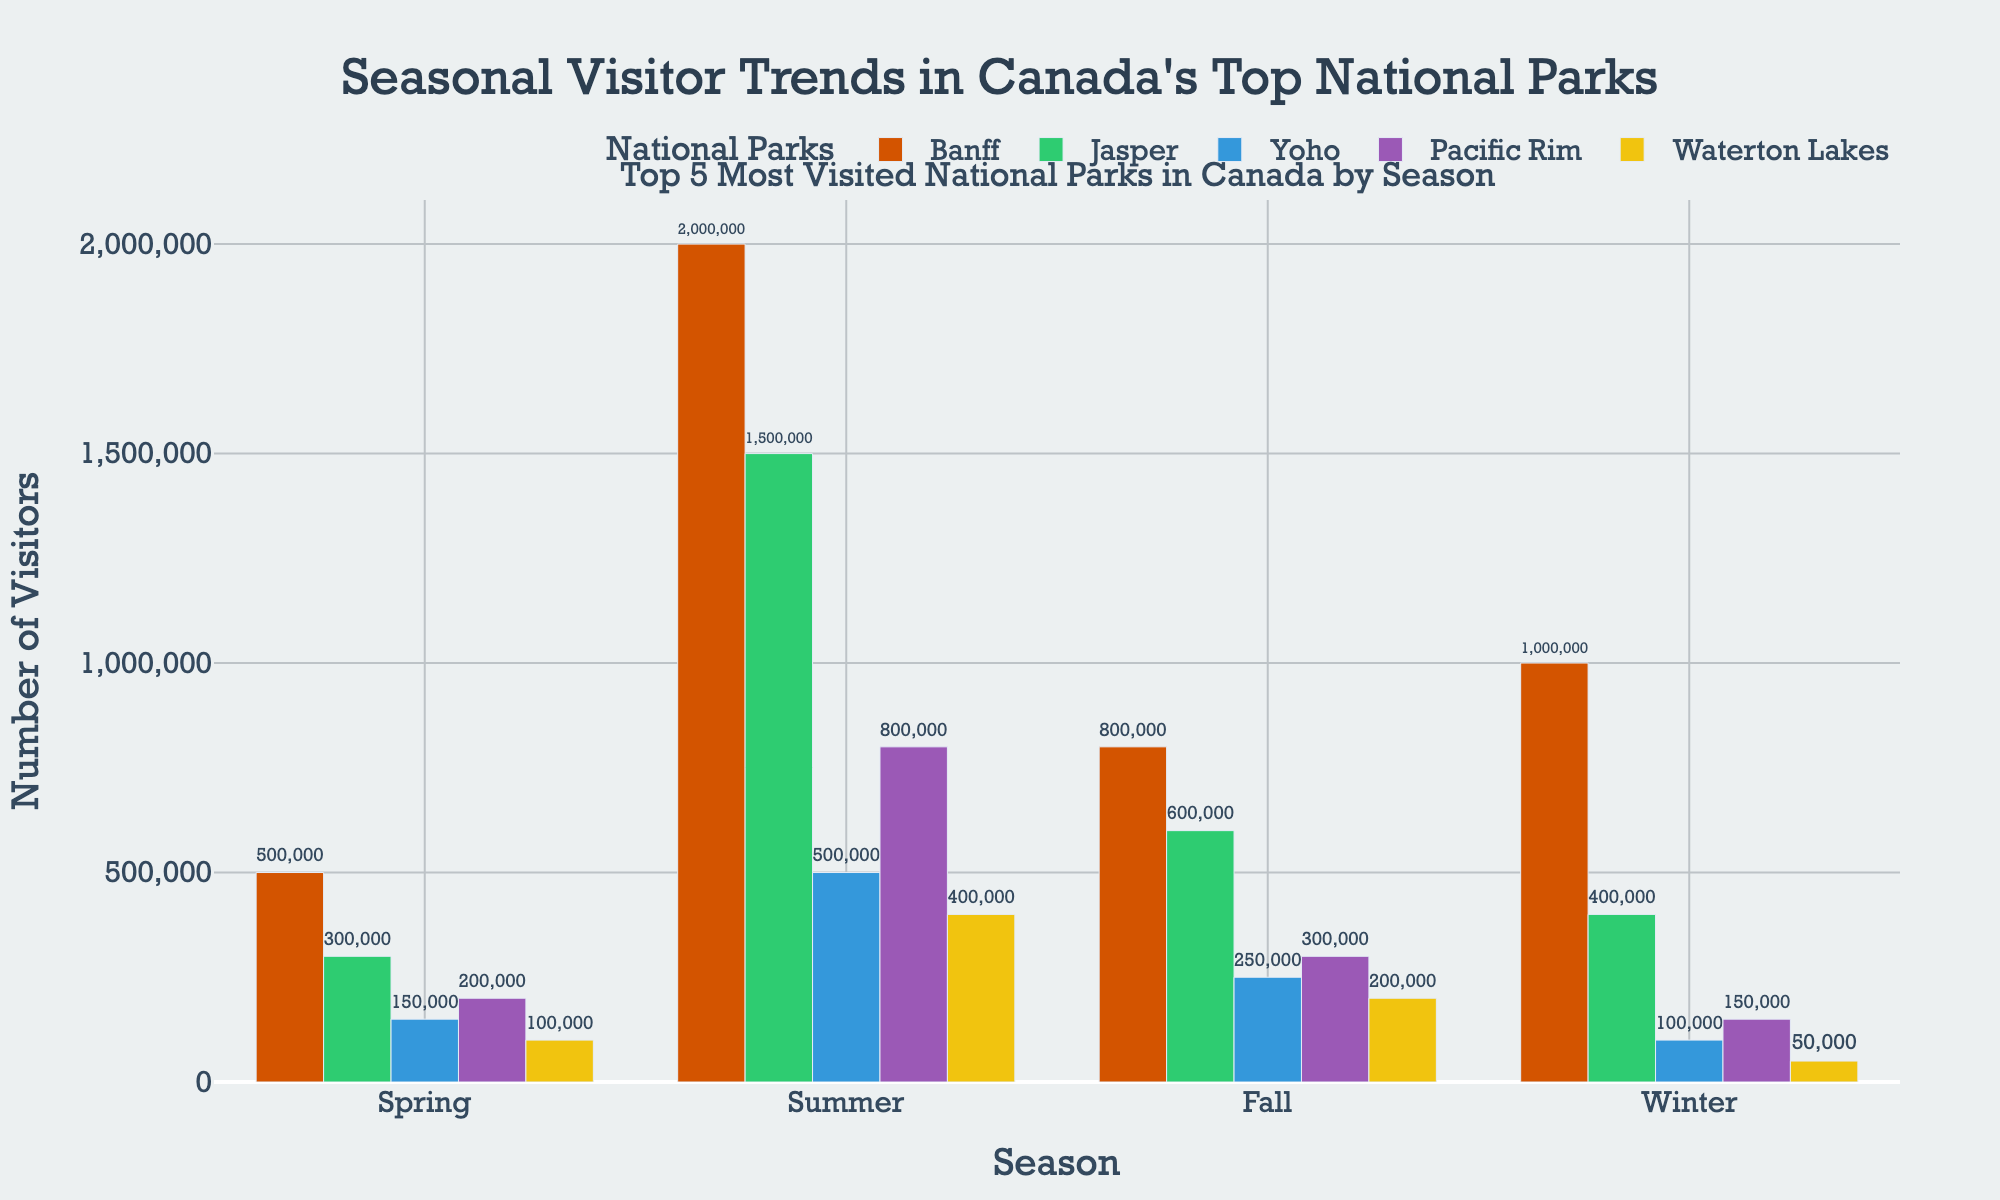Which national park has the highest number of visitors in the winter? The heights of the bars in the winter season show the number of visitors for each park. Banff has the highest bar in this season, signifying the most visitors.
Answer: Banff What is the difference in visitors between summer and winter seasons for Jasper National Park? The summer visitor count for Jasper is 1,500,000 and the winter count is 400,000. The difference is 1,500,000 - 400,000 = 1,100,000.
Answer: 1,100,000 Which season has the lowest number of visitors for Pacific Rim National Park? By comparing the heights of the bars for Pacific Rim in all seasons, the winter season has the shortest bar, indicating the lowest number of visitors.
Answer: Winter What is the total number of visitors to Yoho National Park across all seasons? Sum the visitor counts for Yoho across all seasons: 150,000 (Spring) + 500,000 (Summer) + 250,000 (Fall) + 100,000 (Winter) = 1,000,000.
Answer: 1,000,000 How does the number of summer visitors to Waterton Lakes compare to the number of fall visitors to Banff? The summer visitor count for Waterton Lakes is 400,000. The fall visitor count for Banff is 800,000. By comparison, 800,000 is greater than 400,000.
Answer: Fall visitors to Banff are more Which national park shows the most significant variation in visitor numbers across different seasons? Observe the largest range in bar heights. Banff has the most significant variation between its seasons with 500,000 in spring and 2,000,000 in summer.
Answer: Banff What is the average number of visitors per season for Yoho National Park? Calculate the average visitor count: (150,000 + 500,000 + 250,000 + 100,000) / 4 = 1,000,000 / 4 = 250,000.
Answer: 250,000 How many more visitors does Banff receive in the summer than in the spring? Banff receives 2,000,000 visitors in summer and 500,000 in spring. The difference is 2,000,000 - 500,000 = 1,500,000.
Answer: 1,500,000 Which national park has the smallest difference in visitor counts between spring and fall? Calculate the differences: Banff (300,000), Jasper (300,000), Yoho (100,000), Pacific Rim (100,000), Waterton Lakes (100,000). The smallest is 100,000.
Answer: Yoho, Pacific Rim, Waterton Lakes 